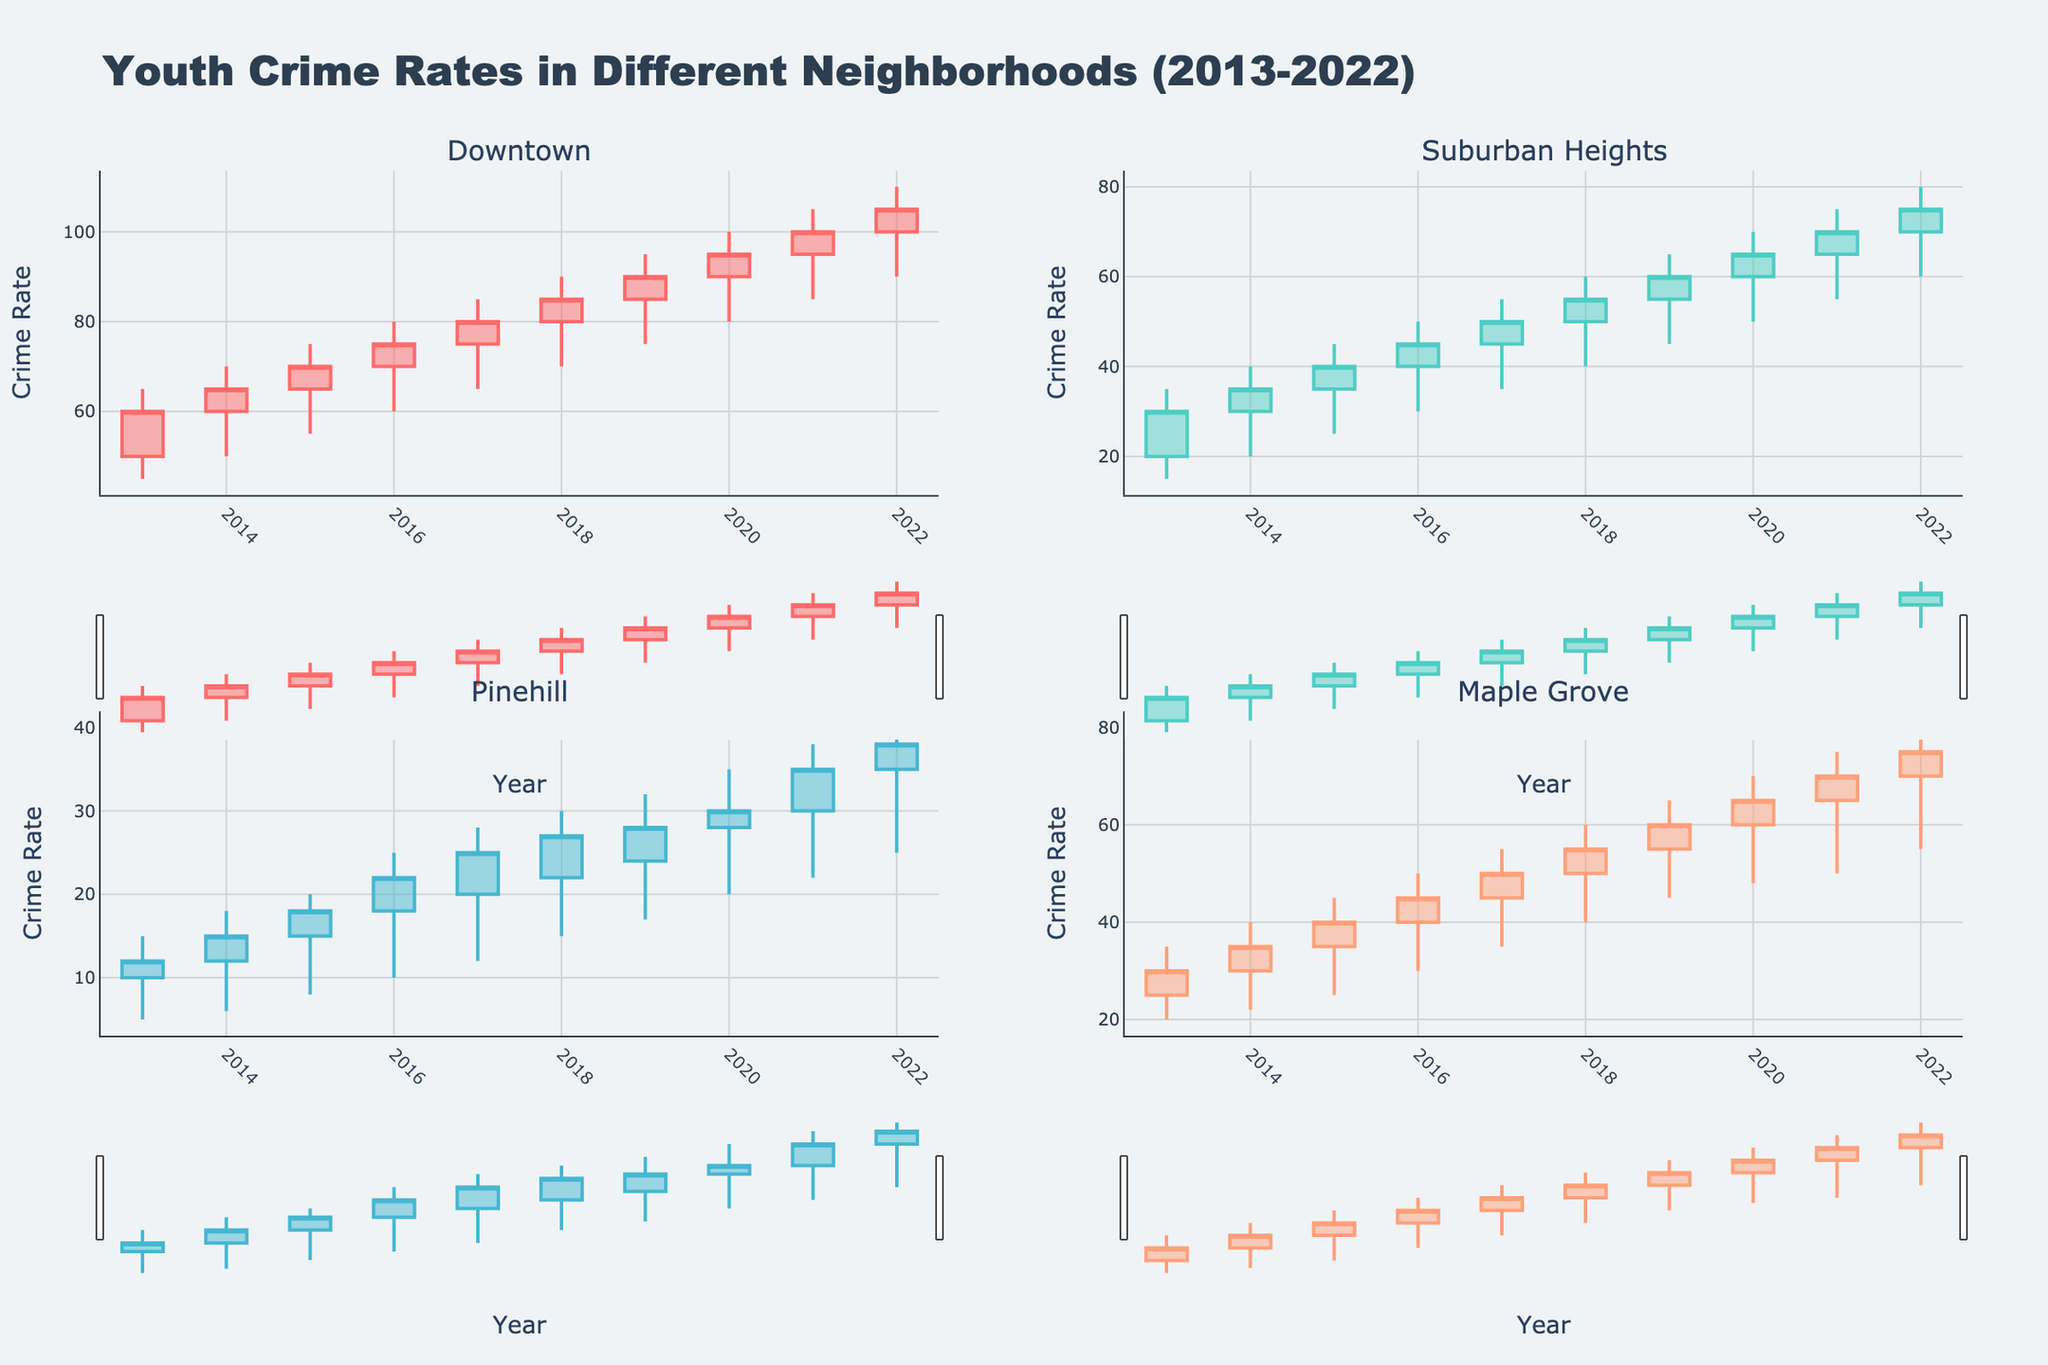What is the title of the figure? The title of the figure is usually prominently displayed at the top and is used to provide a brief summary of what the chart represents. The figure's title is "Youth Crime Rates in Different Neighborhoods (2013-2022)".
Answer: Youth Crime Rates in Different Neighborhoods (2013-2022) How many neighborhoods are displayed in the figure? Count the number of subplot titles. There are four subplot titles, which means four neighborhoods are displayed.
Answer: Four Which neighborhood experienced the highest maximum crime rate in any given year? Look at the 'High' values across all neighborhoods and identify the highest. The Downtown neighborhood has the highest maximum value of 110 in 2022.
Answer: Downtown In which year did Pinehill experience the highest closing crime rate? To find this, locate the highest 'Close' value in the subplot for Pinehill. This value is 38 in 2022.
Answer: 2022 Did the crime rate rise or fall in Suburban Heights between 2021 and 2022? Compare the closing values for 2021 and 2022 in the Suburban Heights subplot. The closing rates are 70 and 75, respectively, indicating a rise.
Answer: Rise Which neighborhood had the lowest starting crime rate in 2013? Check the 'Open' value for each neighborhood in 2013. Pinehill has the lowest starting crime rate of 10.
Answer: Pinehill By how much did the high crime rate in Maple Grove increase from 2015 to 2022? Find the 'High' value for Maple Grove in 2015 and 2022, then calculate the difference. The values are 45 (2015) and 80 (2022), so the increase is 35.
Answer: 35 Which neighborhood shows the most consistent increase in their closing crime rates over the years? Evaluate the closing rates for the years in each neighborhood and identify the one with consistent increases. Downtown has incrementally increasing values every year from 60 (2013) to 105 (2022).
Answer: Downtown 